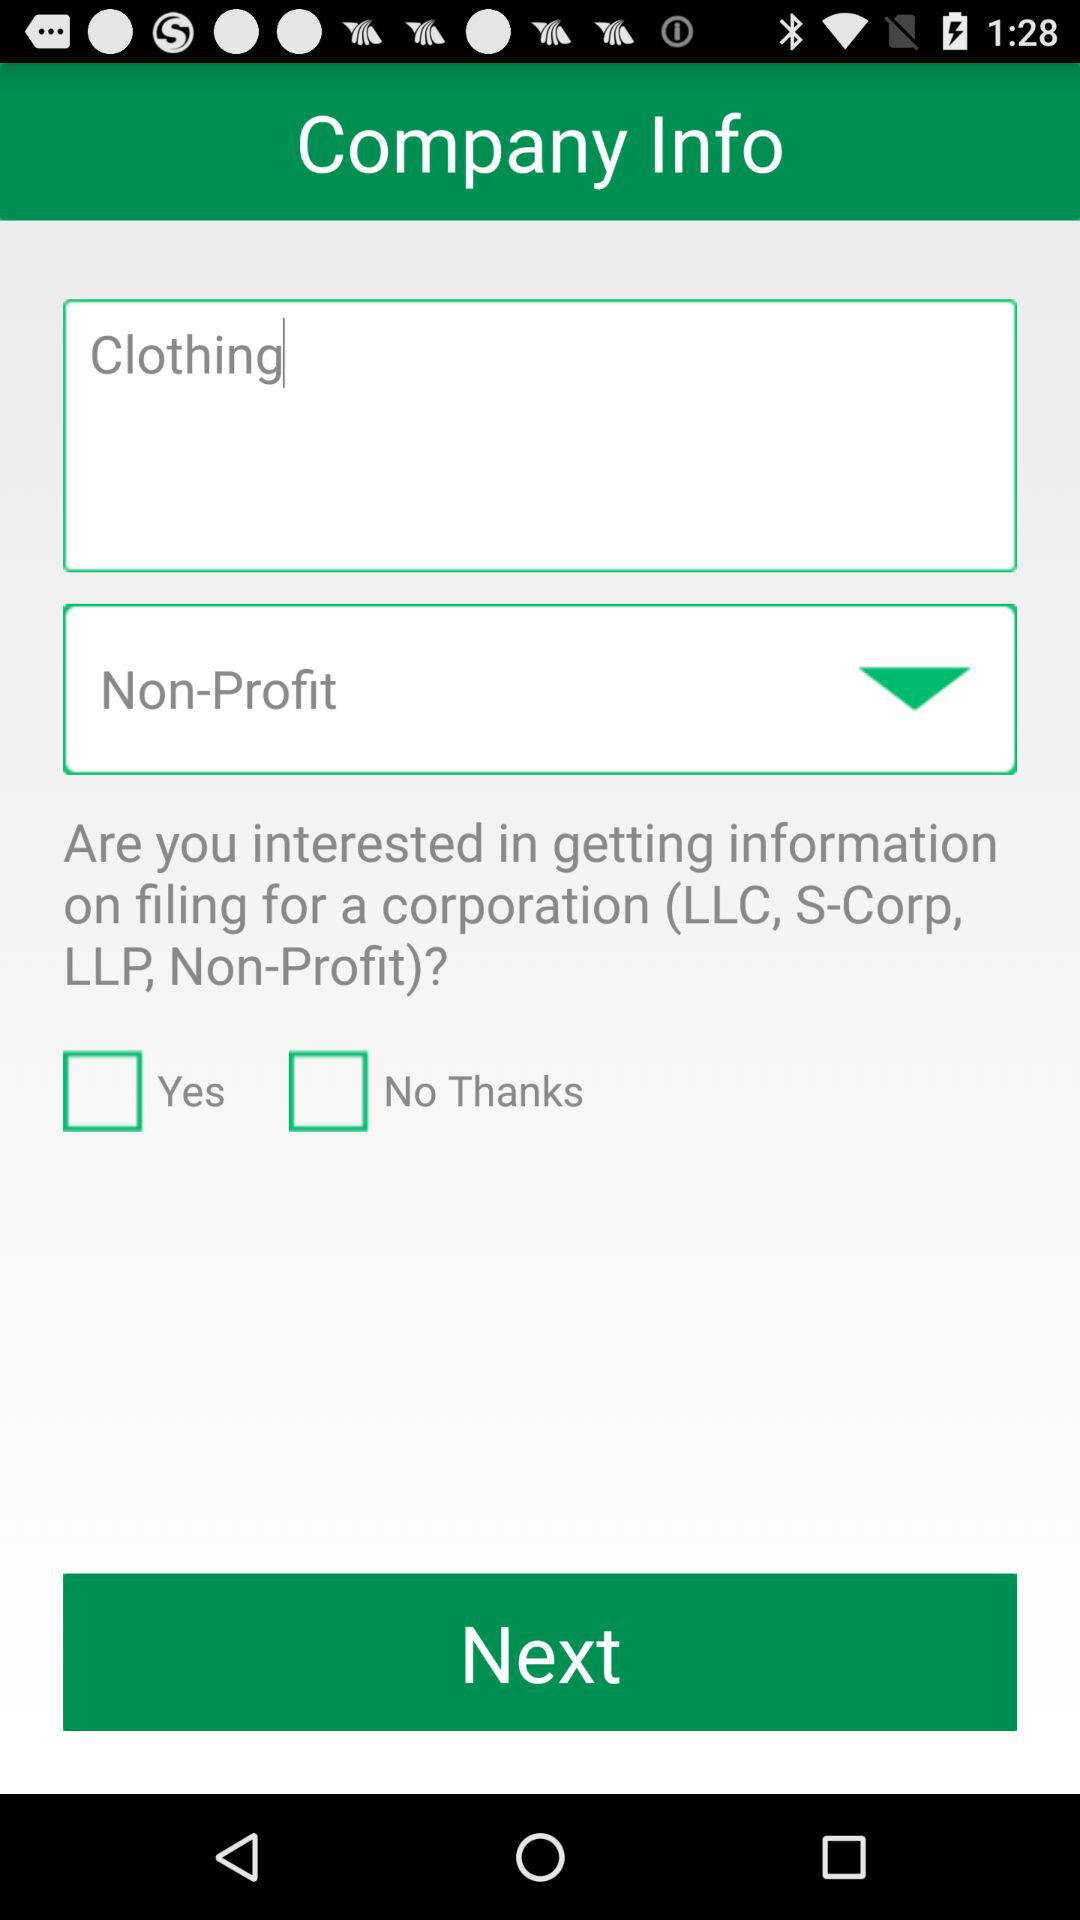How many more checkboxes are there than text inputs?
Answer the question using a single word or phrase. 1 